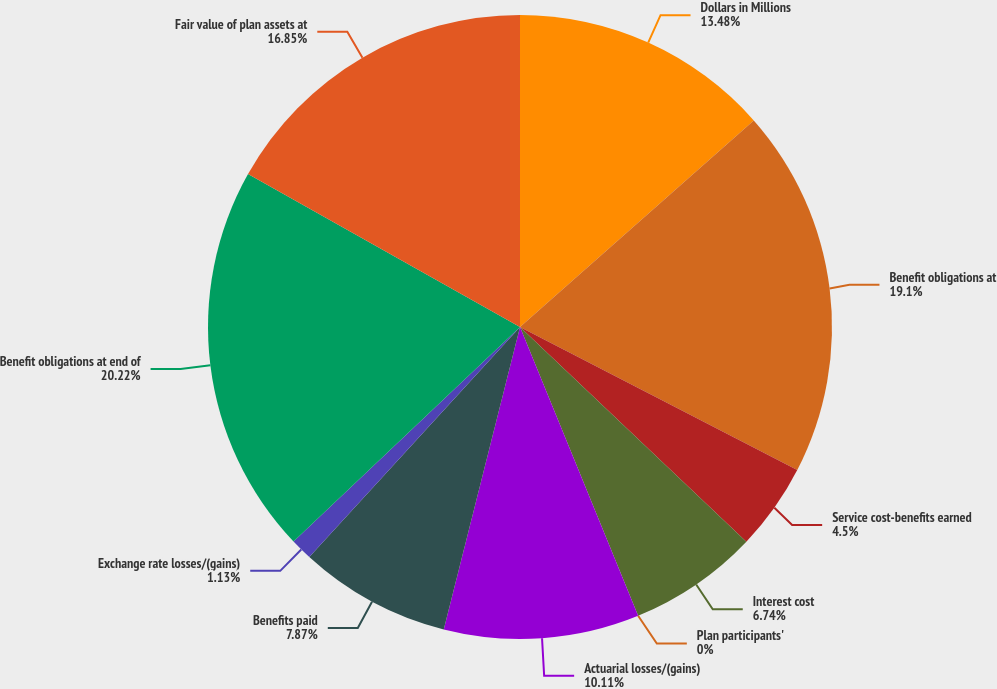Convert chart to OTSL. <chart><loc_0><loc_0><loc_500><loc_500><pie_chart><fcel>Dollars in Millions<fcel>Benefit obligations at<fcel>Service cost-benefits earned<fcel>Interest cost<fcel>Plan participants'<fcel>Actuarial losses/(gains)<fcel>Benefits paid<fcel>Exchange rate losses/(gains)<fcel>Benefit obligations at end of<fcel>Fair value of plan assets at<nl><fcel>13.48%<fcel>19.1%<fcel>4.5%<fcel>6.74%<fcel>0.0%<fcel>10.11%<fcel>7.87%<fcel>1.13%<fcel>20.22%<fcel>16.85%<nl></chart> 